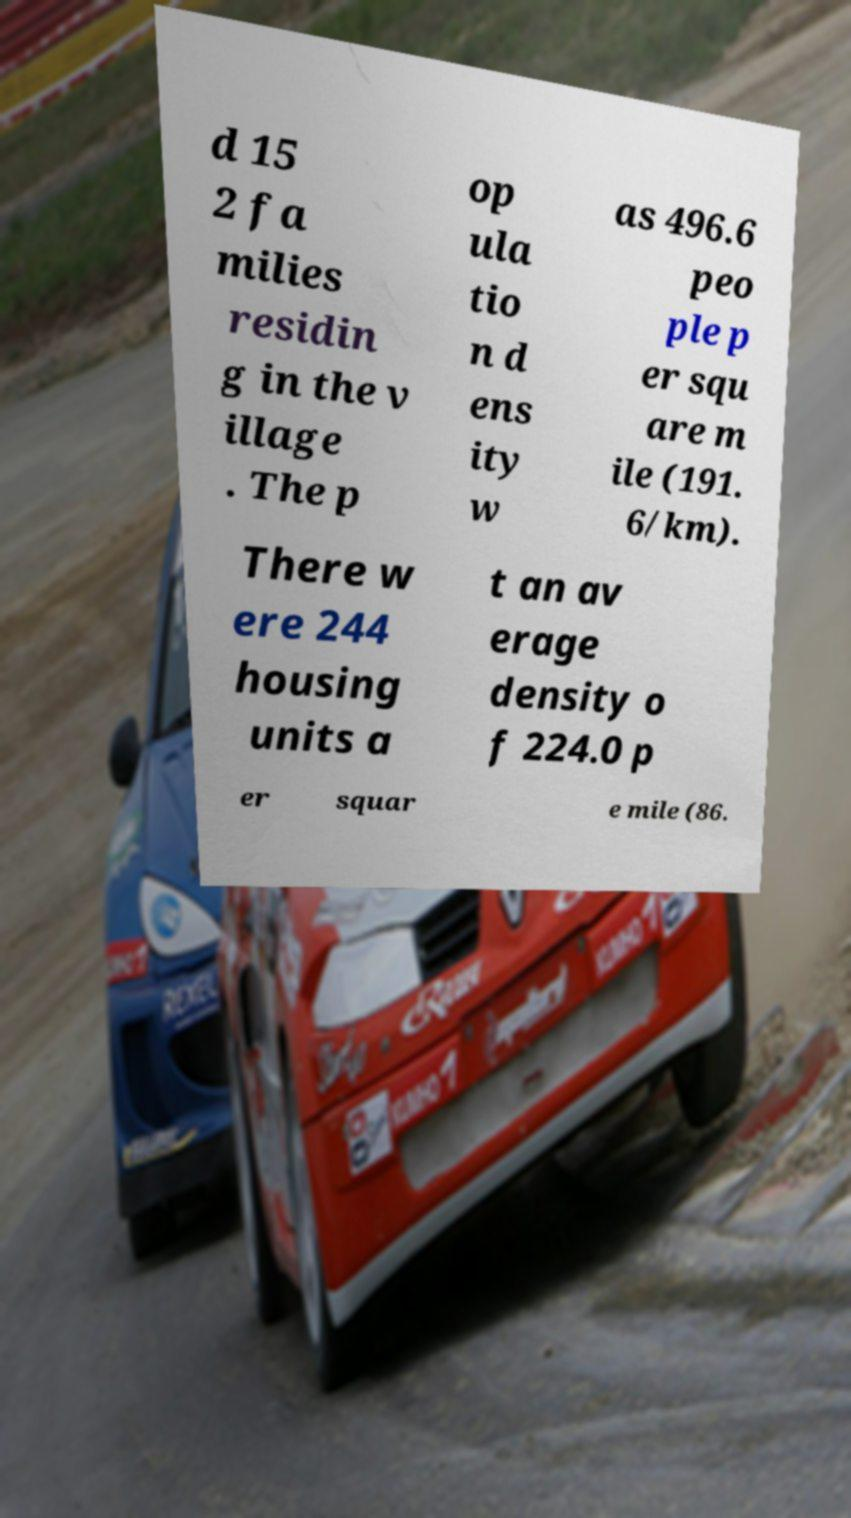Can you accurately transcribe the text from the provided image for me? d 15 2 fa milies residin g in the v illage . The p op ula tio n d ens ity w as 496.6 peo ple p er squ are m ile (191. 6/km). There w ere 244 housing units a t an av erage density o f 224.0 p er squar e mile (86. 